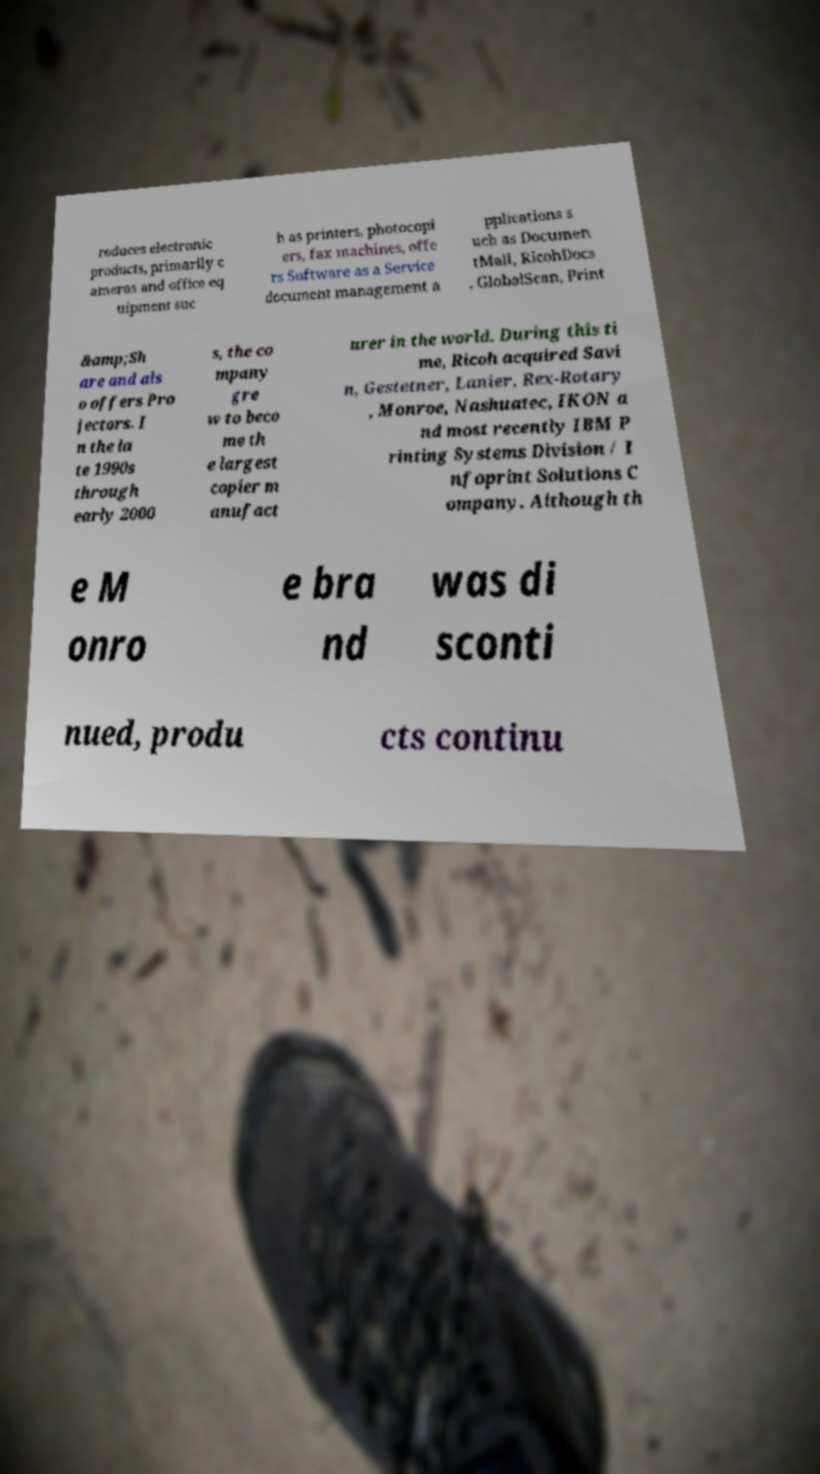Please identify and transcribe the text found in this image. roduces electronic products, primarily c ameras and office eq uipment suc h as printers, photocopi ers, fax machines, offe rs Software as a Service document management a pplications s uch as Documen tMall, RicohDocs , GlobalScan, Print &amp;Sh are and als o offers Pro jectors. I n the la te 1990s through early 2000 s, the co mpany gre w to beco me th e largest copier m anufact urer in the world. During this ti me, Ricoh acquired Savi n, Gestetner, Lanier, Rex-Rotary , Monroe, Nashuatec, IKON a nd most recently IBM P rinting Systems Division / I nfoprint Solutions C ompany. Although th e M onro e bra nd was di sconti nued, produ cts continu 